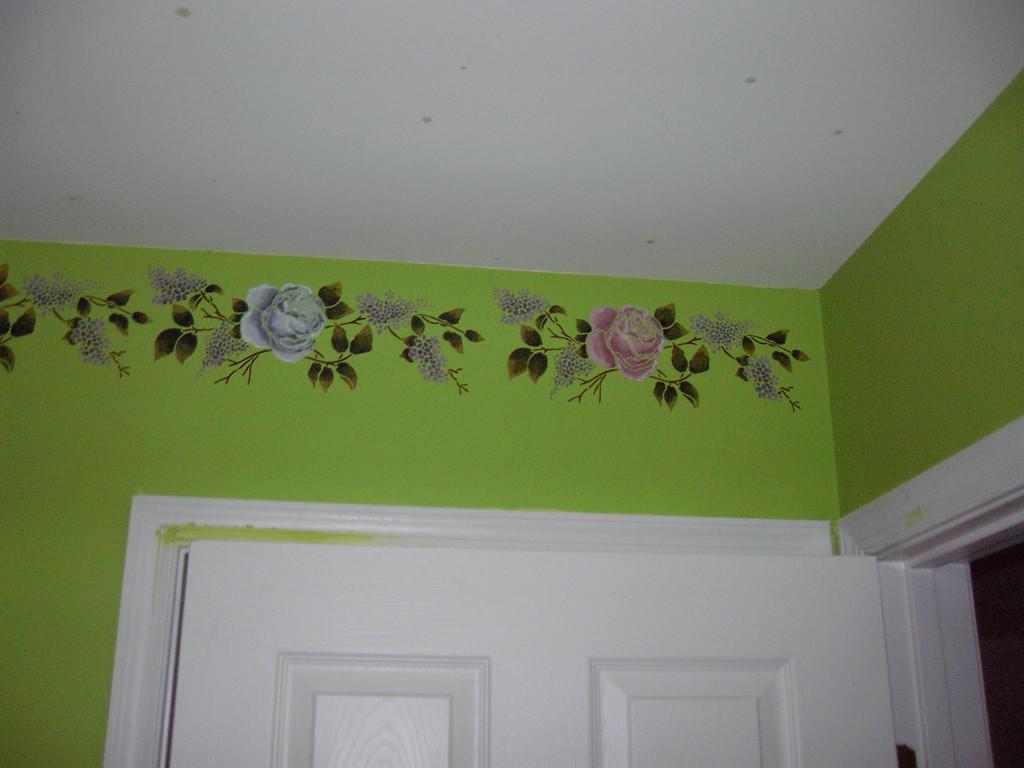In one or two sentences, can you explain what this image depicts? In the picture there is a wall, on the wall there is some design, there is a door. 